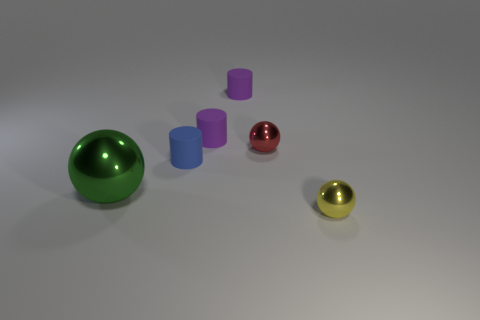What number of tiny things are cylinders or red shiny spheres?
Make the answer very short. 4. The green metallic thing is what size?
Your answer should be compact. Large. Is there any other thing that has the same material as the large sphere?
Your response must be concise. Yes. There is a red shiny thing; how many tiny blue matte cylinders are behind it?
Offer a terse response. 0. What is the size of the yellow thing that is the same shape as the large green metallic thing?
Provide a succinct answer. Small. How big is the metallic sphere that is right of the tiny blue matte thing and in front of the red metallic sphere?
Offer a very short reply. Small. There is a large shiny sphere; is its color the same as the object in front of the green metal ball?
Your answer should be compact. No. How many cyan things are tiny cylinders or large matte blocks?
Provide a short and direct response. 0. What is the shape of the small yellow shiny object?
Keep it short and to the point. Sphere. There is a small metal thing that is in front of the green metallic object; what color is it?
Make the answer very short. Yellow. 